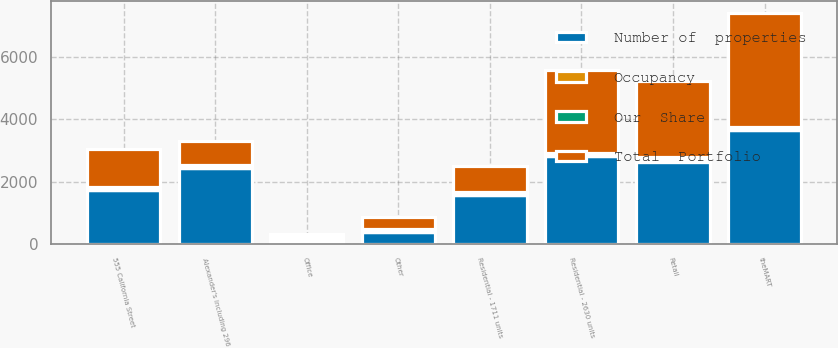<chart> <loc_0><loc_0><loc_500><loc_500><stacked_bar_chart><ecel><fcel>Office<fcel>Retail<fcel>Residential - 1711 units<fcel>Alexander's including 296<fcel>Residential - 2630 units<fcel>Other<fcel>theMART<fcel>555 California Street<nl><fcel>Occupancy<fcel>35<fcel>65<fcel>11<fcel>7<fcel>9<fcel>5<fcel>3<fcel>3<nl><fcel>Number of  properties<fcel>99.85<fcel>2641<fcel>1561<fcel>2419<fcel>2808<fcel>386<fcel>3658<fcel>1736<nl><fcel>Total  Portfolio<fcel>99.85<fcel>2408<fcel>827<fcel>784<fcel>2666<fcel>386<fcel>3649<fcel>1215<nl><fcel>Our  Share<fcel>96.3<fcel>96.2<fcel>95<fcel>99.7<fcel>96.4<fcel>100<fcel>98.5<fcel>93.3<nl></chart> 